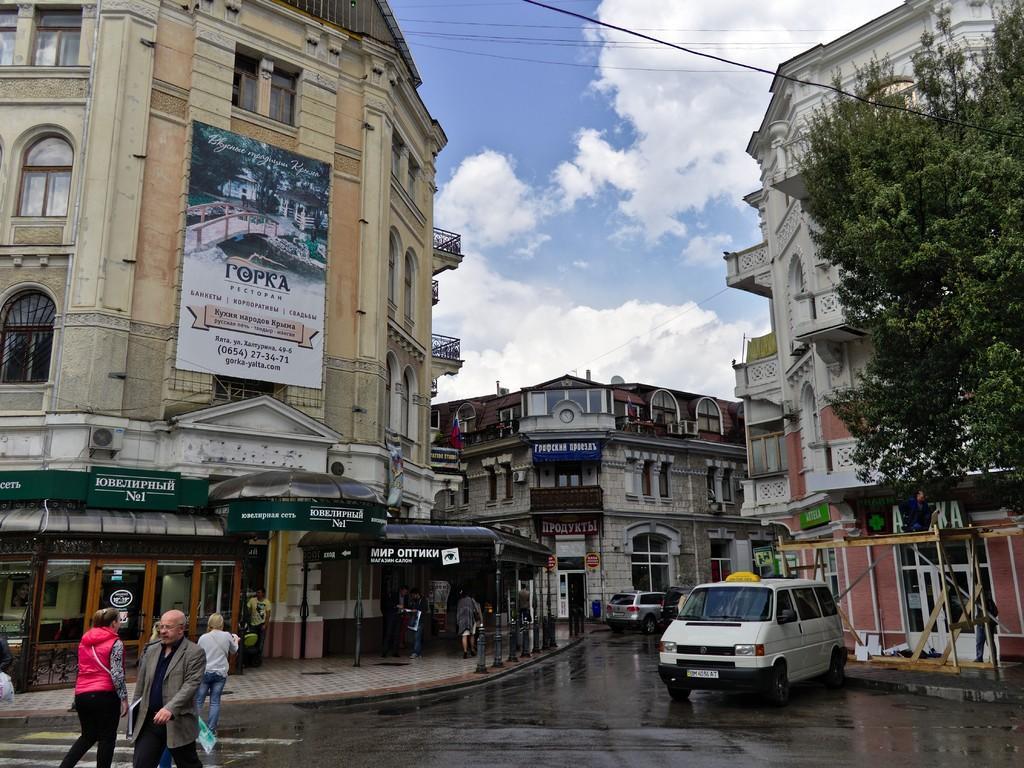Please provide a concise description of this image. This is an outside view, in this picture on the right side and left side there are some buildings and trees. And at the bottom there is a road, on the road there are some vehicles and some persons are walking and there is one footpath. On the footpath there are some people who are walking and also in the center there is a building, on the top of the image there is sky and some wires. On the right side there is one hoarding. 